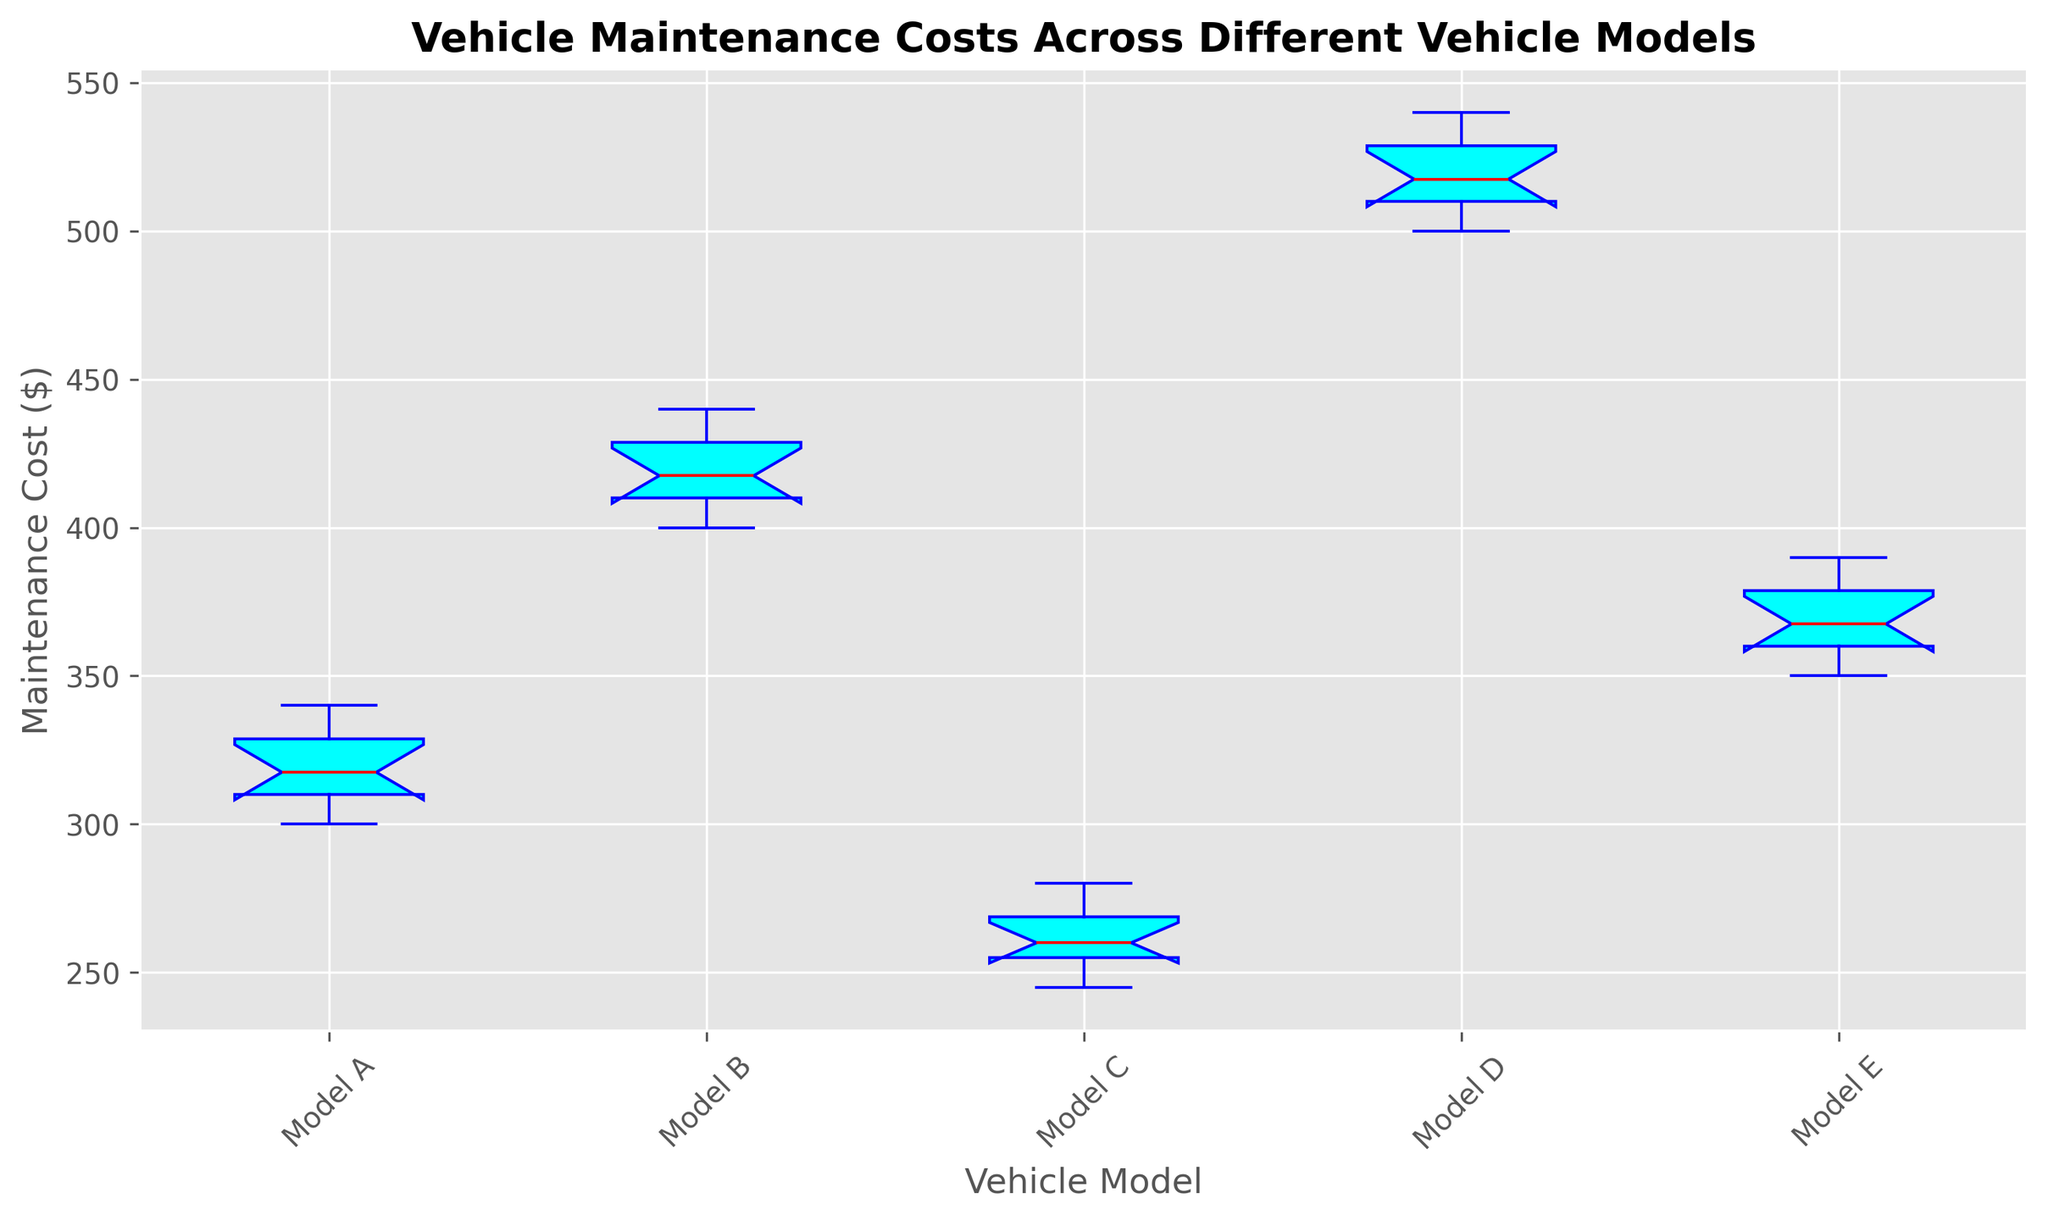What is the median maintenance cost for Model A? The box plot shows the maintenance costs of Model A, with the red line in the middle of the box representing the median. By looking at this line, we can estimate the median value directly.
Answer: 320 Which vehicle model has the highest median maintenance cost? The highest median maintenance cost can be identified by finding the highest red line among all the boxes. From the plot, it is evident that Model D has the highest median line.
Answer: Model D Between Model B and Model E, which has a lower interquartile range (IQR) for maintenance costs? The IQR is the range between the first (bottom of the box) and third quartile (top of the box). By comparing the heights of the boxes, we see that Model B's box is taller (larger IQR) compared to Model E's box.
Answer: Model E What is the approximate range of maintenance costs for Model C? The range of maintenance costs can be determined by finding the lowest and highest points of the whiskers (the lines extending from the box). For Model C, the lowest point is around 245, and the highest is around 280.
Answer: 245 to 280 Which model has the greatest variability in maintenance costs? Variability can be assessed by looking at the total length of the whiskers and the IQR (height of the box). The larger this spread, the greater the variability. Model D displays the greatest variability.
Answer: Model D Which vehicle models have outliers in their maintenance costs? Outliers are represented by red markers outside the whiskers of the box plot. Observing the figure, we can identify any models with such markers.
Answer: None Compare the upper quartile of Model A with the median of Model B. The upper quartile value (top of the box) for Model A can be visually compared to the median value (red line) of Model B. The upper quartile of Model A is slightly below the median of Model B.
Answer: Upper quartile of Model A is lower What is the difference between the highest maintenance cost values in Model A and Model B? The highest point (top whisker) for Model A is around 340, and for Model B, it is around 440. The difference is 440 - 340.
Answer: 100 Which model has the lowest lower quartile, and what is its value? The lower quartile is the bottom line of the box. By comparing the positions, Model C has the lowest lower quartile. The value is around 250.
Answer: Model C, 250 How does the median maintenance cost of Model E compare to the average maintenance cost of Model C? The median maintenance cost of Model E is shown by the red line within the box, whereas the average maintenance cost of Model C can be roughly estimated by summing the individual values and dividing by the count. Model E median is around 370. For Model C, (250 + 260 + 255 + 270 + 265 + 275 + 280 + 245 + 260 + 255)/10 = 261. The median of Model E is higher.
Answer: Model E median is higher 